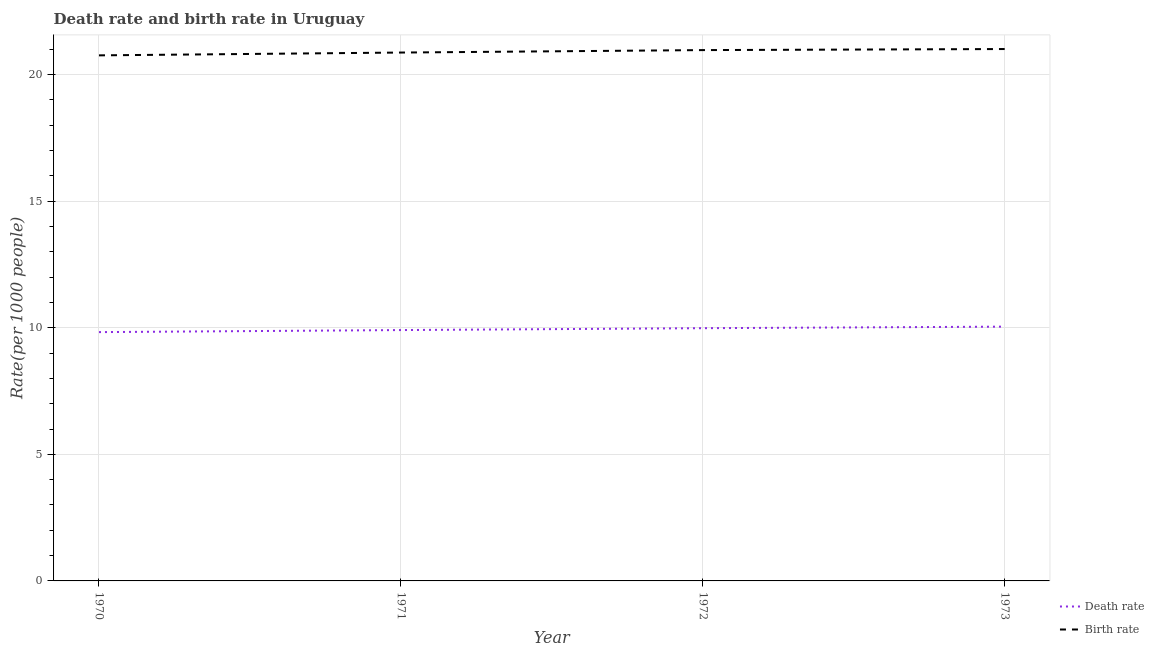What is the death rate in 1972?
Provide a succinct answer. 9.98. Across all years, what is the maximum birth rate?
Offer a terse response. 21.01. Across all years, what is the minimum death rate?
Provide a succinct answer. 9.83. What is the total death rate in the graph?
Ensure brevity in your answer.  39.77. What is the difference between the birth rate in 1971 and that in 1973?
Give a very brief answer. -0.14. What is the difference between the birth rate in 1973 and the death rate in 1970?
Ensure brevity in your answer.  11.18. What is the average birth rate per year?
Keep it short and to the point. 20.9. In the year 1973, what is the difference between the birth rate and death rate?
Give a very brief answer. 10.97. What is the ratio of the birth rate in 1971 to that in 1972?
Your response must be concise. 1. Is the difference between the birth rate in 1971 and 1972 greater than the difference between the death rate in 1971 and 1972?
Provide a succinct answer. No. What is the difference between the highest and the second highest death rate?
Offer a very short reply. 0.06. In how many years, is the death rate greater than the average death rate taken over all years?
Provide a short and direct response. 2. Is the sum of the birth rate in 1970 and 1972 greater than the maximum death rate across all years?
Give a very brief answer. Yes. Is the birth rate strictly greater than the death rate over the years?
Provide a short and direct response. Yes. How many lines are there?
Your response must be concise. 2. What is the difference between two consecutive major ticks on the Y-axis?
Ensure brevity in your answer.  5. Does the graph contain grids?
Provide a short and direct response. Yes. How many legend labels are there?
Give a very brief answer. 2. What is the title of the graph?
Your answer should be very brief. Death rate and birth rate in Uruguay. What is the label or title of the Y-axis?
Your response must be concise. Rate(per 1000 people). What is the Rate(per 1000 people) in Death rate in 1970?
Offer a terse response. 9.83. What is the Rate(per 1000 people) in Birth rate in 1970?
Offer a terse response. 20.76. What is the Rate(per 1000 people) in Death rate in 1971?
Your answer should be compact. 9.91. What is the Rate(per 1000 people) of Birth rate in 1971?
Your response must be concise. 20.87. What is the Rate(per 1000 people) of Death rate in 1972?
Provide a succinct answer. 9.98. What is the Rate(per 1000 people) in Birth rate in 1972?
Keep it short and to the point. 20.97. What is the Rate(per 1000 people) of Death rate in 1973?
Ensure brevity in your answer.  10.04. What is the Rate(per 1000 people) in Birth rate in 1973?
Your answer should be very brief. 21.01. Across all years, what is the maximum Rate(per 1000 people) of Death rate?
Your response must be concise. 10.04. Across all years, what is the maximum Rate(per 1000 people) of Birth rate?
Your answer should be very brief. 21.01. Across all years, what is the minimum Rate(per 1000 people) of Death rate?
Keep it short and to the point. 9.83. Across all years, what is the minimum Rate(per 1000 people) in Birth rate?
Provide a short and direct response. 20.76. What is the total Rate(per 1000 people) in Death rate in the graph?
Offer a very short reply. 39.77. What is the total Rate(per 1000 people) of Birth rate in the graph?
Give a very brief answer. 83.62. What is the difference between the Rate(per 1000 people) of Death rate in 1970 and that in 1971?
Offer a very short reply. -0.08. What is the difference between the Rate(per 1000 people) of Birth rate in 1970 and that in 1971?
Keep it short and to the point. -0.11. What is the difference between the Rate(per 1000 people) of Death rate in 1970 and that in 1972?
Offer a very short reply. -0.15. What is the difference between the Rate(per 1000 people) of Birth rate in 1970 and that in 1972?
Keep it short and to the point. -0.21. What is the difference between the Rate(per 1000 people) of Death rate in 1970 and that in 1973?
Give a very brief answer. -0.22. What is the difference between the Rate(per 1000 people) in Birth rate in 1970 and that in 1973?
Your response must be concise. -0.25. What is the difference between the Rate(per 1000 people) of Death rate in 1971 and that in 1972?
Provide a succinct answer. -0.07. What is the difference between the Rate(per 1000 people) in Birth rate in 1971 and that in 1972?
Your answer should be very brief. -0.1. What is the difference between the Rate(per 1000 people) in Death rate in 1971 and that in 1973?
Keep it short and to the point. -0.14. What is the difference between the Rate(per 1000 people) in Birth rate in 1971 and that in 1973?
Your answer should be compact. -0.14. What is the difference between the Rate(per 1000 people) in Death rate in 1972 and that in 1973?
Keep it short and to the point. -0.06. What is the difference between the Rate(per 1000 people) in Birth rate in 1972 and that in 1973?
Make the answer very short. -0.04. What is the difference between the Rate(per 1000 people) in Death rate in 1970 and the Rate(per 1000 people) in Birth rate in 1971?
Provide a short and direct response. -11.04. What is the difference between the Rate(per 1000 people) in Death rate in 1970 and the Rate(per 1000 people) in Birth rate in 1972?
Make the answer very short. -11.14. What is the difference between the Rate(per 1000 people) of Death rate in 1970 and the Rate(per 1000 people) of Birth rate in 1973?
Provide a succinct answer. -11.18. What is the difference between the Rate(per 1000 people) in Death rate in 1971 and the Rate(per 1000 people) in Birth rate in 1972?
Give a very brief answer. -11.06. What is the difference between the Rate(per 1000 people) in Death rate in 1971 and the Rate(per 1000 people) in Birth rate in 1973?
Ensure brevity in your answer.  -11.1. What is the difference between the Rate(per 1000 people) in Death rate in 1972 and the Rate(per 1000 people) in Birth rate in 1973?
Your answer should be very brief. -11.03. What is the average Rate(per 1000 people) in Death rate per year?
Your answer should be very brief. 9.94. What is the average Rate(per 1000 people) of Birth rate per year?
Keep it short and to the point. 20.9. In the year 1970, what is the difference between the Rate(per 1000 people) in Death rate and Rate(per 1000 people) in Birth rate?
Your answer should be very brief. -10.93. In the year 1971, what is the difference between the Rate(per 1000 people) in Death rate and Rate(per 1000 people) in Birth rate?
Ensure brevity in your answer.  -10.96. In the year 1972, what is the difference between the Rate(per 1000 people) in Death rate and Rate(per 1000 people) in Birth rate?
Make the answer very short. -10.99. In the year 1973, what is the difference between the Rate(per 1000 people) in Death rate and Rate(per 1000 people) in Birth rate?
Keep it short and to the point. -10.97. What is the ratio of the Rate(per 1000 people) of Death rate in 1970 to that in 1971?
Offer a very short reply. 0.99. What is the ratio of the Rate(per 1000 people) of Death rate in 1970 to that in 1972?
Your response must be concise. 0.98. What is the ratio of the Rate(per 1000 people) of Death rate in 1970 to that in 1973?
Provide a short and direct response. 0.98. What is the ratio of the Rate(per 1000 people) of Birth rate in 1970 to that in 1973?
Provide a succinct answer. 0.99. What is the ratio of the Rate(per 1000 people) of Death rate in 1971 to that in 1972?
Provide a short and direct response. 0.99. What is the ratio of the Rate(per 1000 people) of Death rate in 1971 to that in 1973?
Offer a very short reply. 0.99. What is the ratio of the Rate(per 1000 people) in Birth rate in 1972 to that in 1973?
Your answer should be very brief. 1. What is the difference between the highest and the second highest Rate(per 1000 people) in Death rate?
Give a very brief answer. 0.06. What is the difference between the highest and the second highest Rate(per 1000 people) of Birth rate?
Your answer should be compact. 0.04. What is the difference between the highest and the lowest Rate(per 1000 people) in Death rate?
Make the answer very short. 0.22. What is the difference between the highest and the lowest Rate(per 1000 people) of Birth rate?
Make the answer very short. 0.25. 